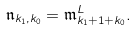<formula> <loc_0><loc_0><loc_500><loc_500>\mathfrak { n } _ { k _ { 1 } , k _ { 0 } } = \mathfrak { m } ^ { L } _ { k _ { 1 } + 1 + k _ { 0 } } .</formula> 